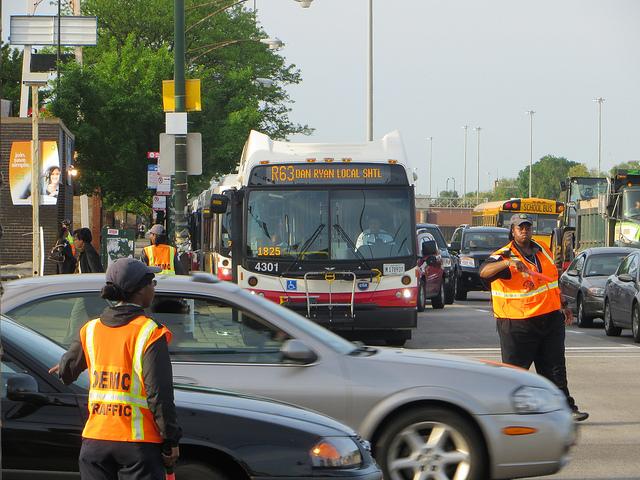What does the back of the orange vest say?
Keep it brief. Traffic. What is the number of the bus?
Short answer required. 4301. How many people are directing traffic?
Concise answer only. 3. 